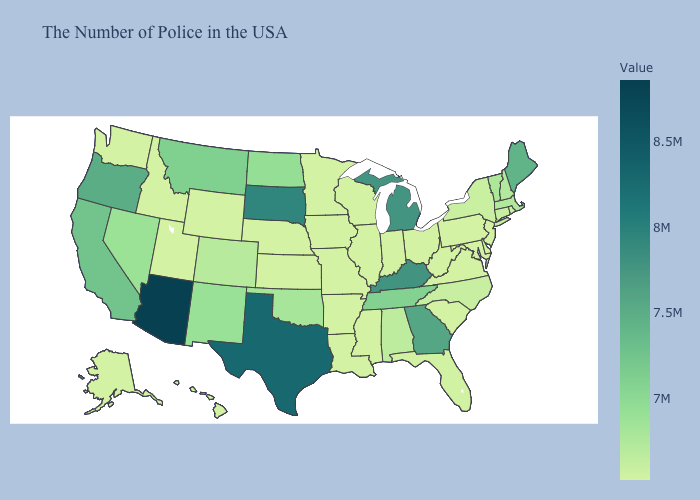Does Missouri have the highest value in the MidWest?
Keep it brief. No. Does Ohio have the highest value in the USA?
Concise answer only. No. Among the states that border Iowa , which have the highest value?
Be succinct. South Dakota. Does Arizona have the highest value in the West?
Be succinct. Yes. Among the states that border Texas , does Louisiana have the highest value?
Concise answer only. No. Which states have the highest value in the USA?
Quick response, please. Arizona. Which states hav the highest value in the Northeast?
Be succinct. Maine. Does South Carolina have the highest value in the South?
Concise answer only. No. Which states have the lowest value in the USA?
Be succinct. New Jersey, Delaware, Maryland, Pennsylvania, Virginia, South Carolina, West Virginia, Ohio, Indiana, Wisconsin, Illinois, Mississippi, Louisiana, Missouri, Arkansas, Minnesota, Iowa, Kansas, Nebraska, Wyoming, Utah, Idaho, Washington, Alaska, Hawaii. 